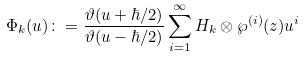<formula> <loc_0><loc_0><loc_500><loc_500>\Phi _ { k } ( u ) \colon = \frac { \vartheta ( u + \hbar { / } 2 ) } { \vartheta ( u - \hbar { / } 2 ) } \sum _ { i = 1 } ^ { \infty } H _ { k } \otimes \wp ^ { ( i ) } ( z ) u ^ { i }</formula> 